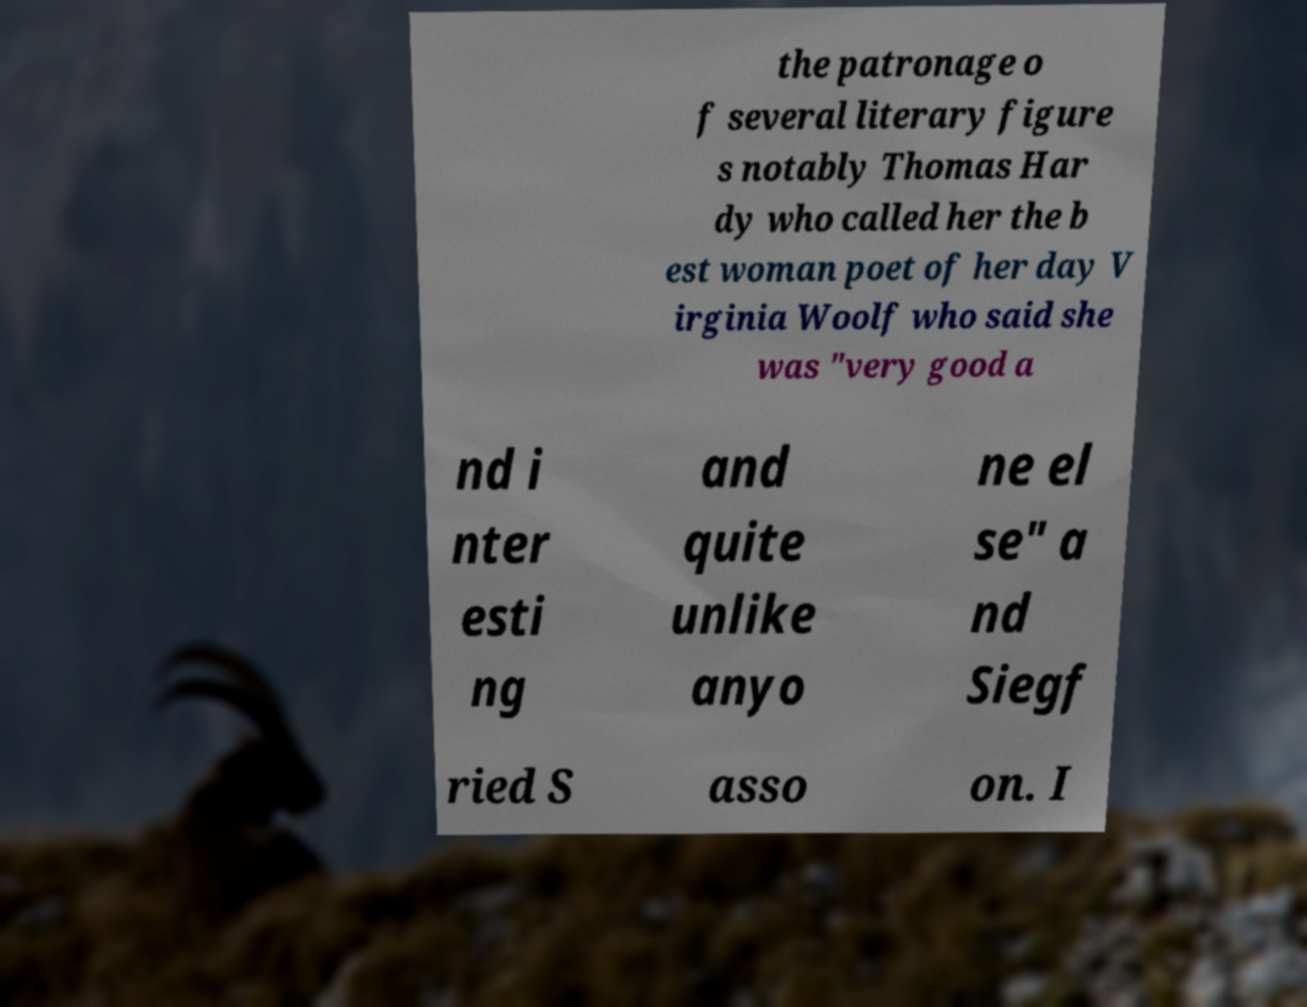For documentation purposes, I need the text within this image transcribed. Could you provide that? the patronage o f several literary figure s notably Thomas Har dy who called her the b est woman poet of her day V irginia Woolf who said she was "very good a nd i nter esti ng and quite unlike anyo ne el se" a nd Siegf ried S asso on. I 